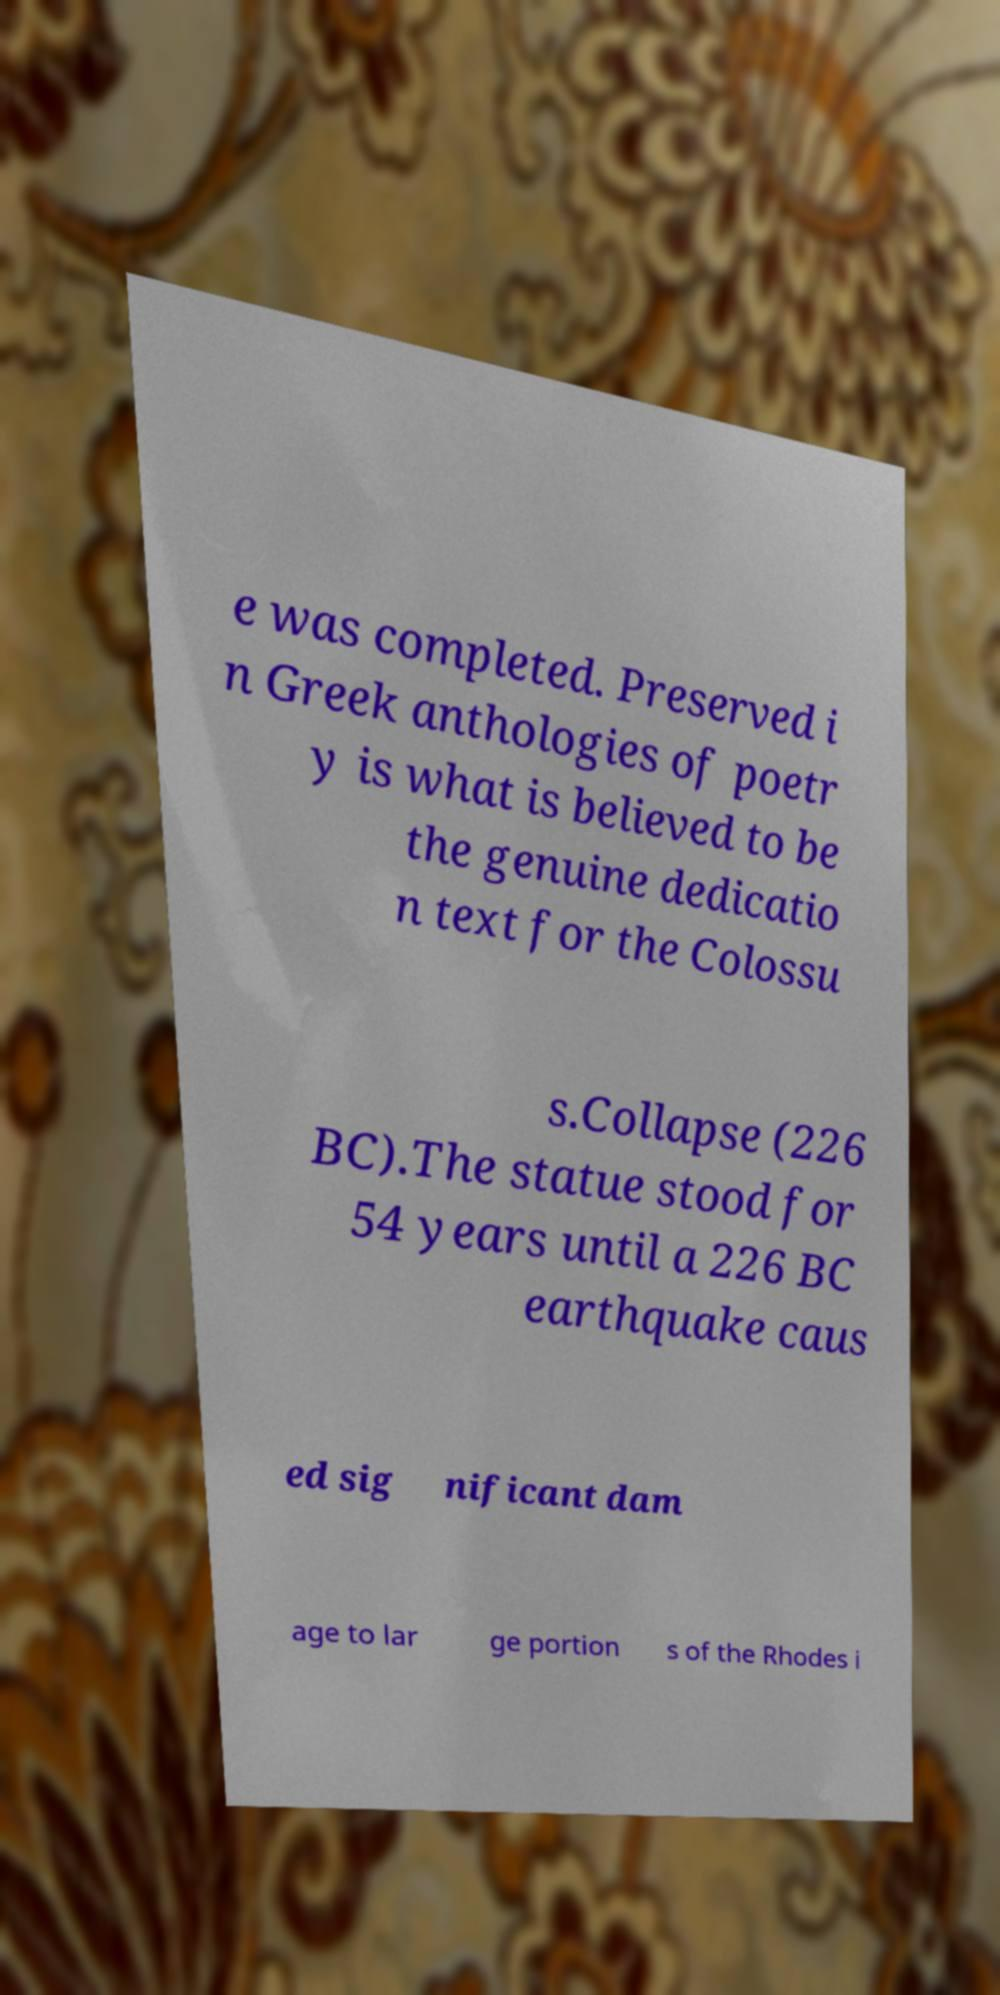Can you accurately transcribe the text from the provided image for me? e was completed. Preserved i n Greek anthologies of poetr y is what is believed to be the genuine dedicatio n text for the Colossu s.Collapse (226 BC).The statue stood for 54 years until a 226 BC earthquake caus ed sig nificant dam age to lar ge portion s of the Rhodes i 